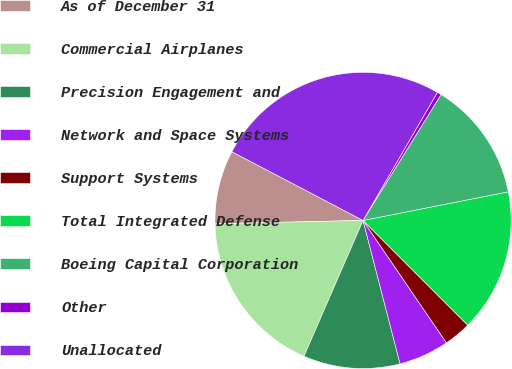<chart> <loc_0><loc_0><loc_500><loc_500><pie_chart><fcel>As of December 31<fcel>Commercial Airplanes<fcel>Precision Engagement and<fcel>Network and Space Systems<fcel>Support Systems<fcel>Total Integrated Defense<fcel>Boeing Capital Corporation<fcel>Other<fcel>Unallocated<nl><fcel>8.03%<fcel>18.12%<fcel>10.55%<fcel>5.5%<fcel>2.98%<fcel>15.6%<fcel>13.07%<fcel>0.46%<fcel>25.69%<nl></chart> 